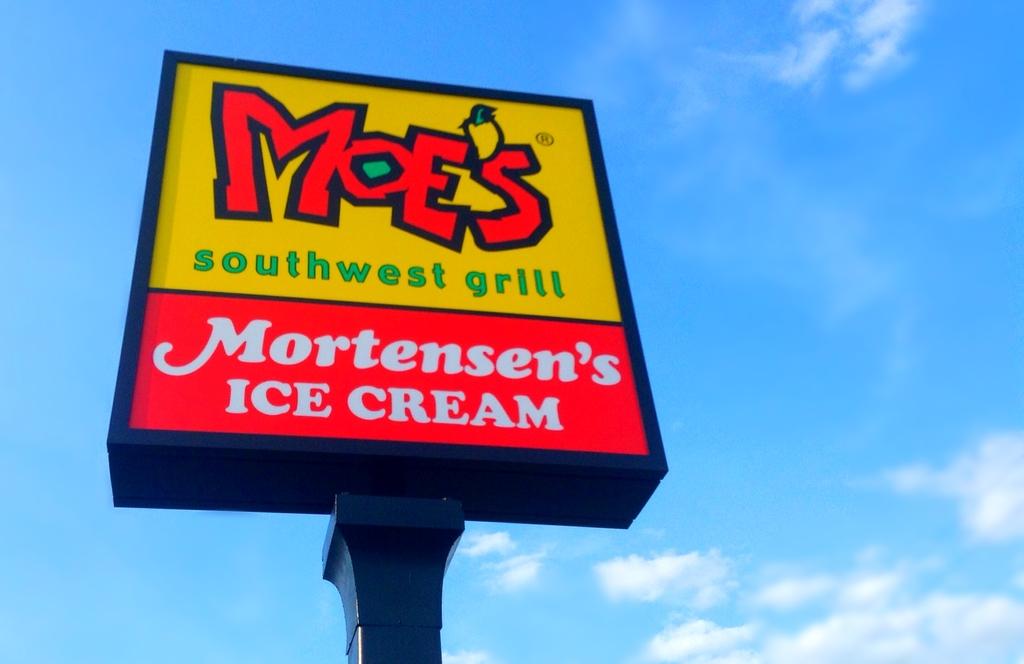What is the name of the restraunt on top called?
Provide a short and direct response. Moes. What ice cream do they have?
Ensure brevity in your answer.  Mortensen's. 